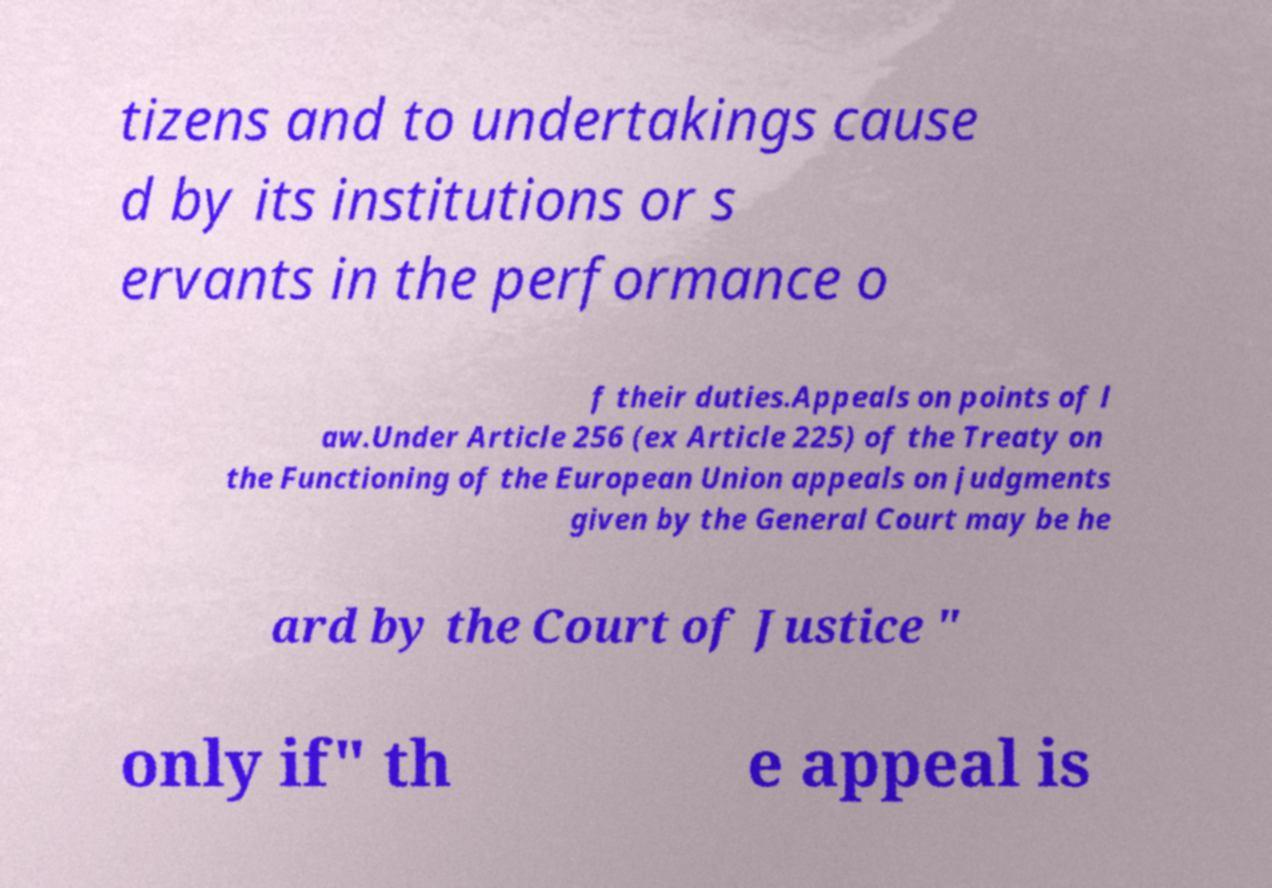Can you read and provide the text displayed in the image?This photo seems to have some interesting text. Can you extract and type it out for me? tizens and to undertakings cause d by its institutions or s ervants in the performance o f their duties.Appeals on points of l aw.Under Article 256 (ex Article 225) of the Treaty on the Functioning of the European Union appeals on judgments given by the General Court may be he ard by the Court of Justice " only if" th e appeal is 